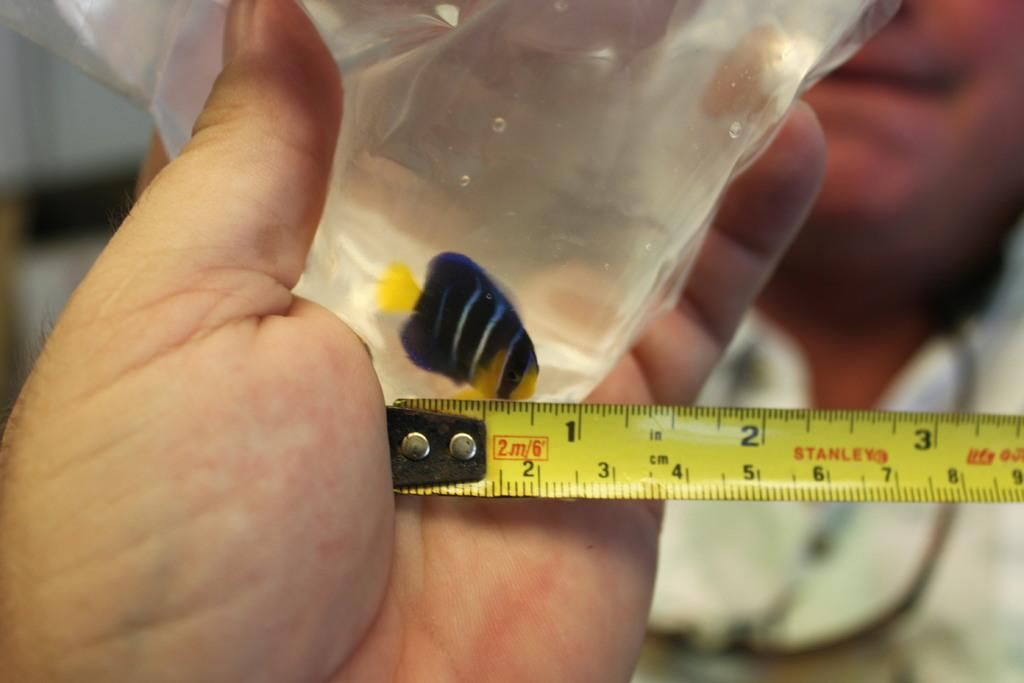<image>
Write a terse but informative summary of the picture. A man is measuring a fish in a bag using Stanley's brand measuring tape. 